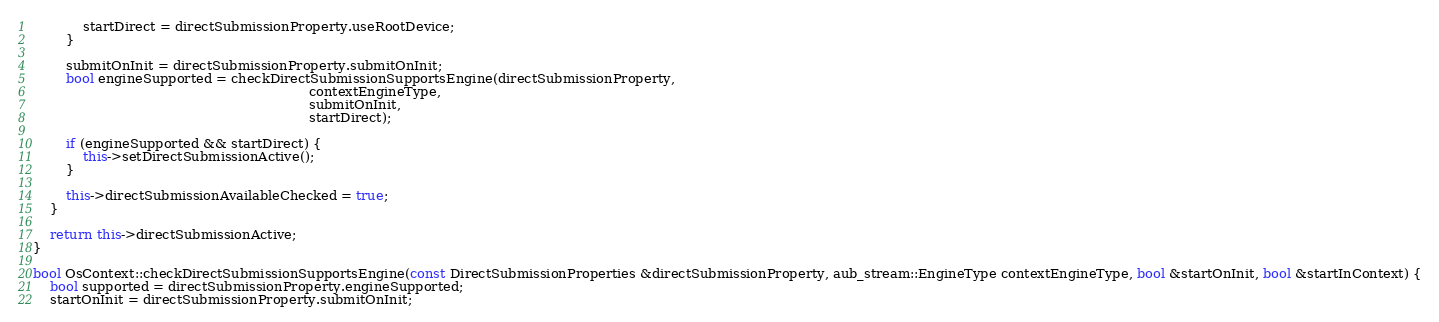<code> <loc_0><loc_0><loc_500><loc_500><_C++_>            startDirect = directSubmissionProperty.useRootDevice;
        }

        submitOnInit = directSubmissionProperty.submitOnInit;
        bool engineSupported = checkDirectSubmissionSupportsEngine(directSubmissionProperty,
                                                                   contextEngineType,
                                                                   submitOnInit,
                                                                   startDirect);

        if (engineSupported && startDirect) {
            this->setDirectSubmissionActive();
        }

        this->directSubmissionAvailableChecked = true;
    }

    return this->directSubmissionActive;
}

bool OsContext::checkDirectSubmissionSupportsEngine(const DirectSubmissionProperties &directSubmissionProperty, aub_stream::EngineType contextEngineType, bool &startOnInit, bool &startInContext) {
    bool supported = directSubmissionProperty.engineSupported;
    startOnInit = directSubmissionProperty.submitOnInit;</code> 